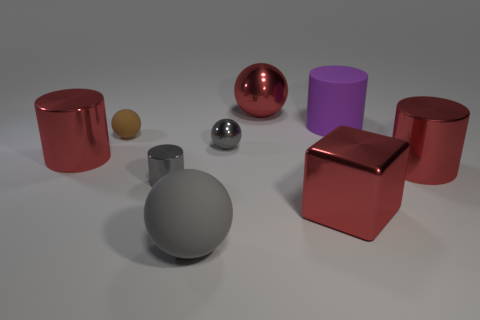How many cylinders are either large rubber things or large metal things?
Your response must be concise. 3. Do the cube and the large purple object have the same material?
Make the answer very short. No. What number of other objects are the same color as the block?
Offer a very short reply. 3. What shape is the large red object left of the brown ball?
Your response must be concise. Cylinder. What number of objects are big purple matte objects or tiny green matte objects?
Ensure brevity in your answer.  1. Do the gray metal cylinder and the red cylinder that is to the right of the big gray matte object have the same size?
Provide a succinct answer. No. How many other things are the same material as the brown ball?
Your response must be concise. 2. How many things are big matte objects that are in front of the brown rubber ball or big rubber things left of the purple rubber thing?
Provide a short and direct response. 1. There is a small brown thing that is the same shape as the gray matte thing; what is it made of?
Provide a succinct answer. Rubber. Are any small brown shiny spheres visible?
Keep it short and to the point. No. 